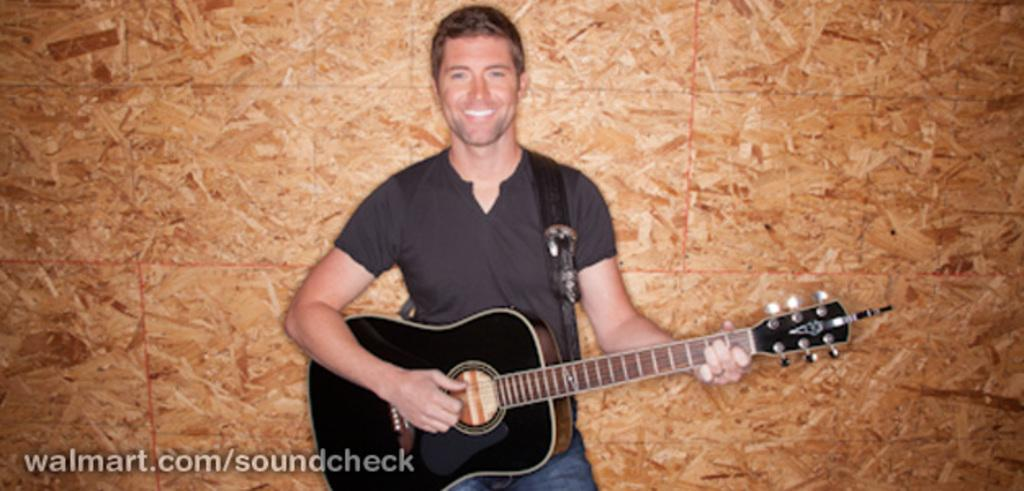What is the main subject of the image? The main subject of the image is a man. What is the man wearing in the image? The man is wearing a black t-shirt in the image. What is the man doing in the image? The man is standing and playing a guitar in the image. What is the man's facial expression in the image? The man is smiling in the image. What type of vase is the man smashing with his guitar in the image? There is no vase present in the image, nor is the man smashing anything with his guitar. 